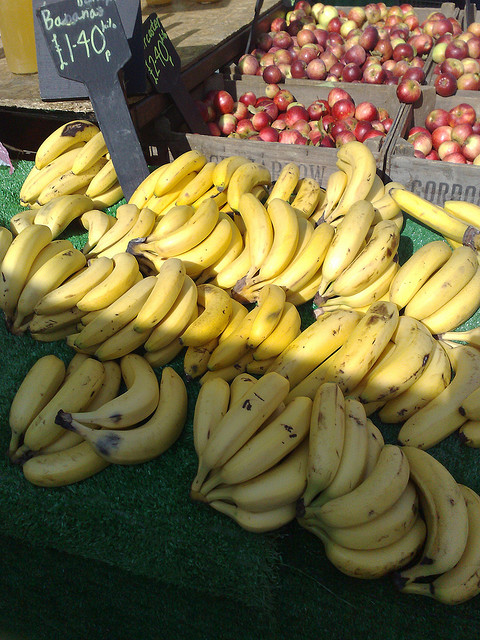Are bananas always sold in bunches like in this image? Bananas are often sold in bunches or 'hands', still connected by the stem, as seen in this photo. This helps keep the bananas together during transport and may prolong their freshness. However, they can also be purchased individually, allowing customers to select the exact quantity they need. What's the best way to store bananas to keep them fresh? To keep bananas fresh, store them at room temperature, away from direct sunlight and heat. If you need to slow down the ripening process, you can place them in the refrigerator. The skin will darken, but the fruit inside will remain fresh for a longer period. 